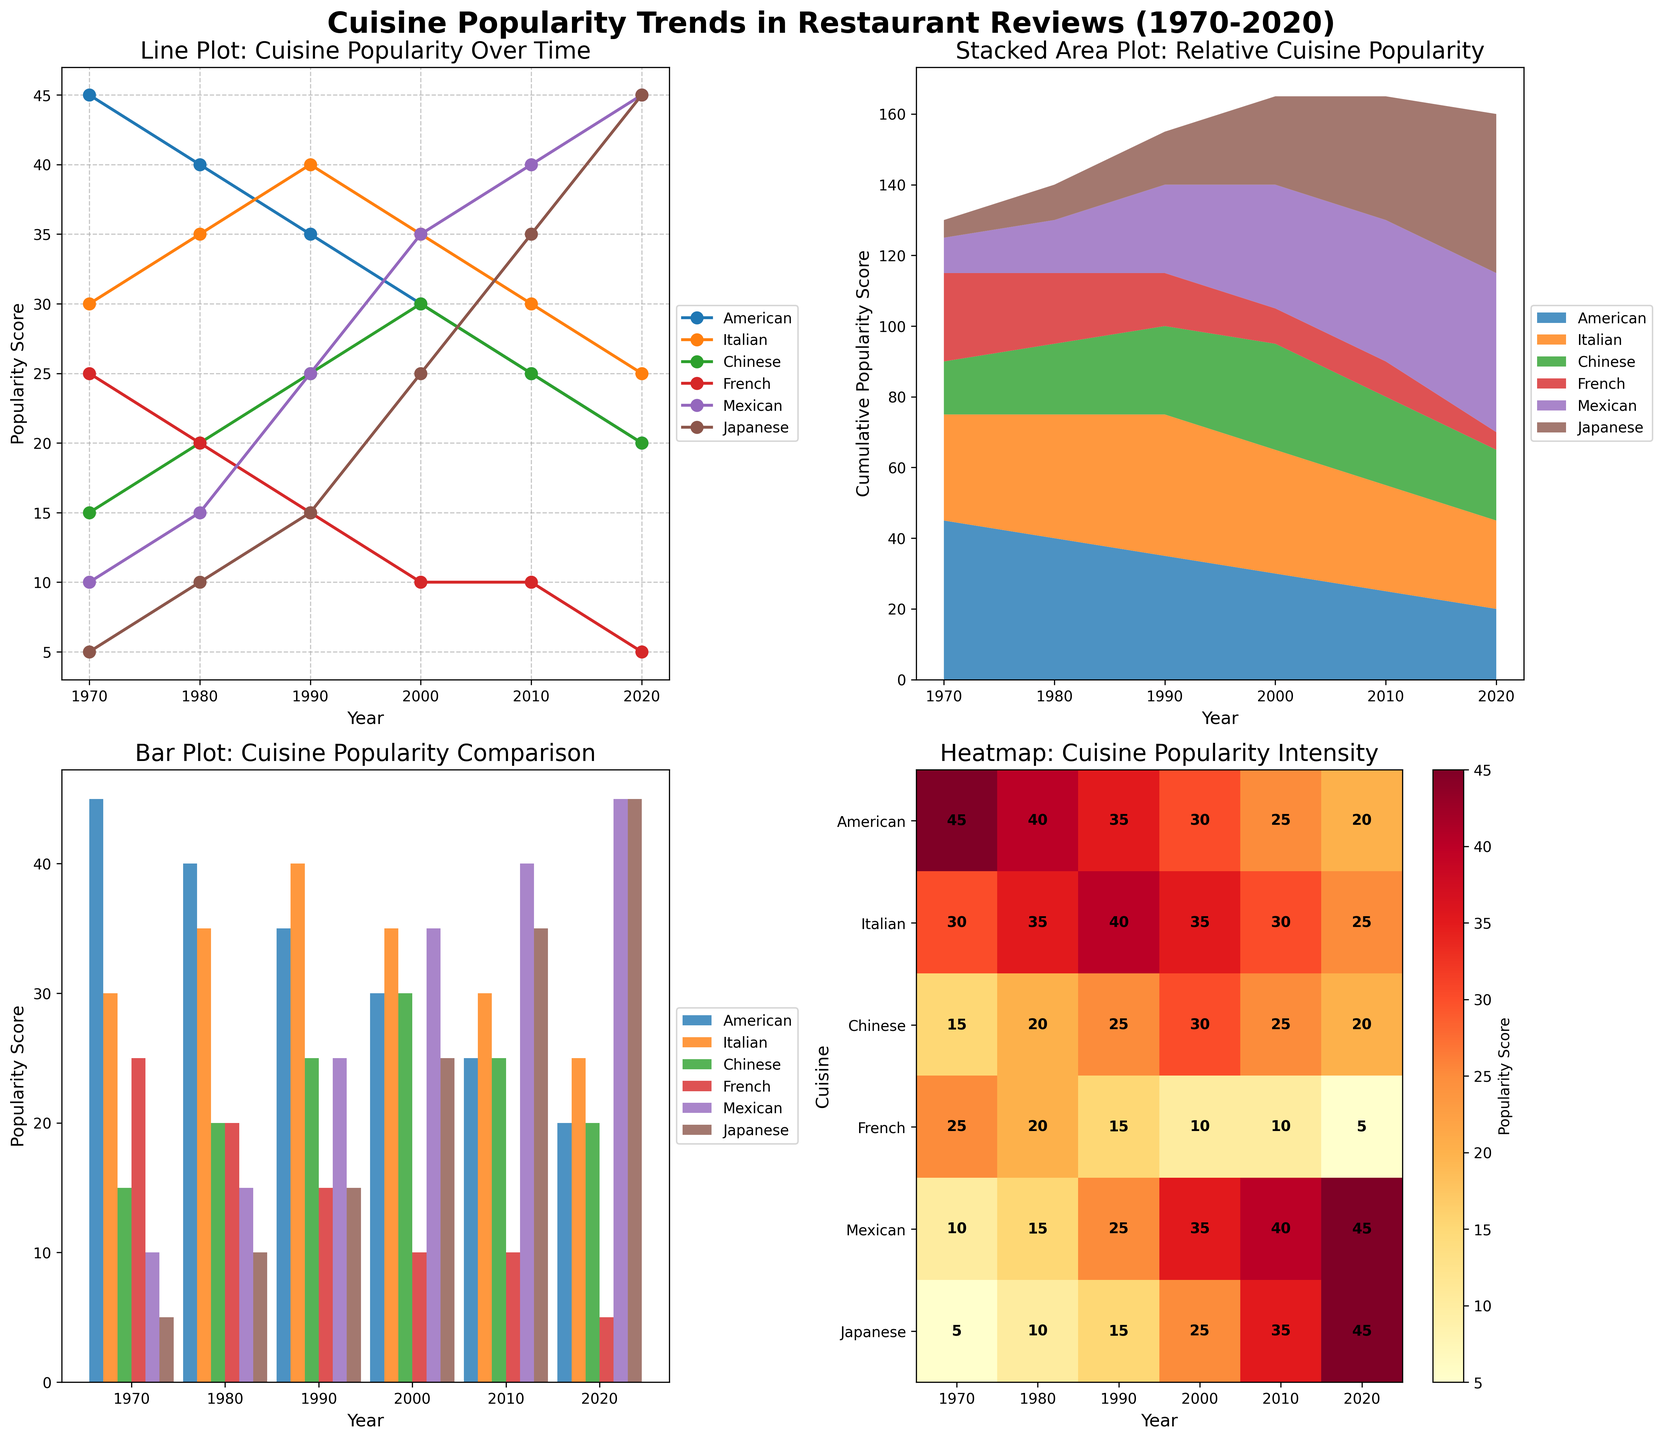Which cuisine had the highest popularity score in 1970? In the line plot and bar plot, we can see the numerical values for each cuisine in 1970. The American cuisine had a score of 45, which is the highest compared to others.
Answer: American Between which years did Japanese cuisine see the most significant increase in popularity? From the line plot, we observe the trend line for Japanese cuisine. The steepest increase in popularity occurs between 2000 and 2010, jumping from 25 to 35.
Answer: 2000 to 2010 How did the popularity of French cuisine change from 1970 to 2020? The line plot and bar plot show that French cuisine's popularity consistently decreased from 25 in 1970 to 5 in 2020.
Answer: Decreased Which two cuisines had equal popularity scores in 2020? By checking the line plot and bar plot for 2020, both Mexican and Japanese cuisines had a popularity score of 45.
Answer: Mexican and Japanese By how much did the popularity of Mexican cuisine increase from 1970 to 2020? From the line plot, Mexican cuisine's score increased from 10 in 1970 to 45 in 2020. The difference is 45 - 10 = 35.
Answer: 35 Which cuisine showed a decrease in popularity every decade? In the heatmap and line plot, American cuisine's popularity decreased every decade from 45 in 1970 to 20 in 2020.
Answer: American What is the cumulative popularity score for all cuisines in 2010 according to the stacked area plot? Adding the scores of all cuisines for 2010 from the stacked area plot: 25 (American) + 30 (Italian) + 25 (Chinese) + 10 (French) + 40 (Mexican) + 35 (Japanese) = 165.
Answer: 165 Which cuisine had the second-highest popularity score in 1990? Looking at the plots for 1990, Italian cuisine had the second-highest score of 40.
Answer: Italian In which decade did Chinese cuisine peak in its popularity? The line plot indicates that Chinese cuisine reached its peak popularity in 2000 with a score of 30.
Answer: 2000 